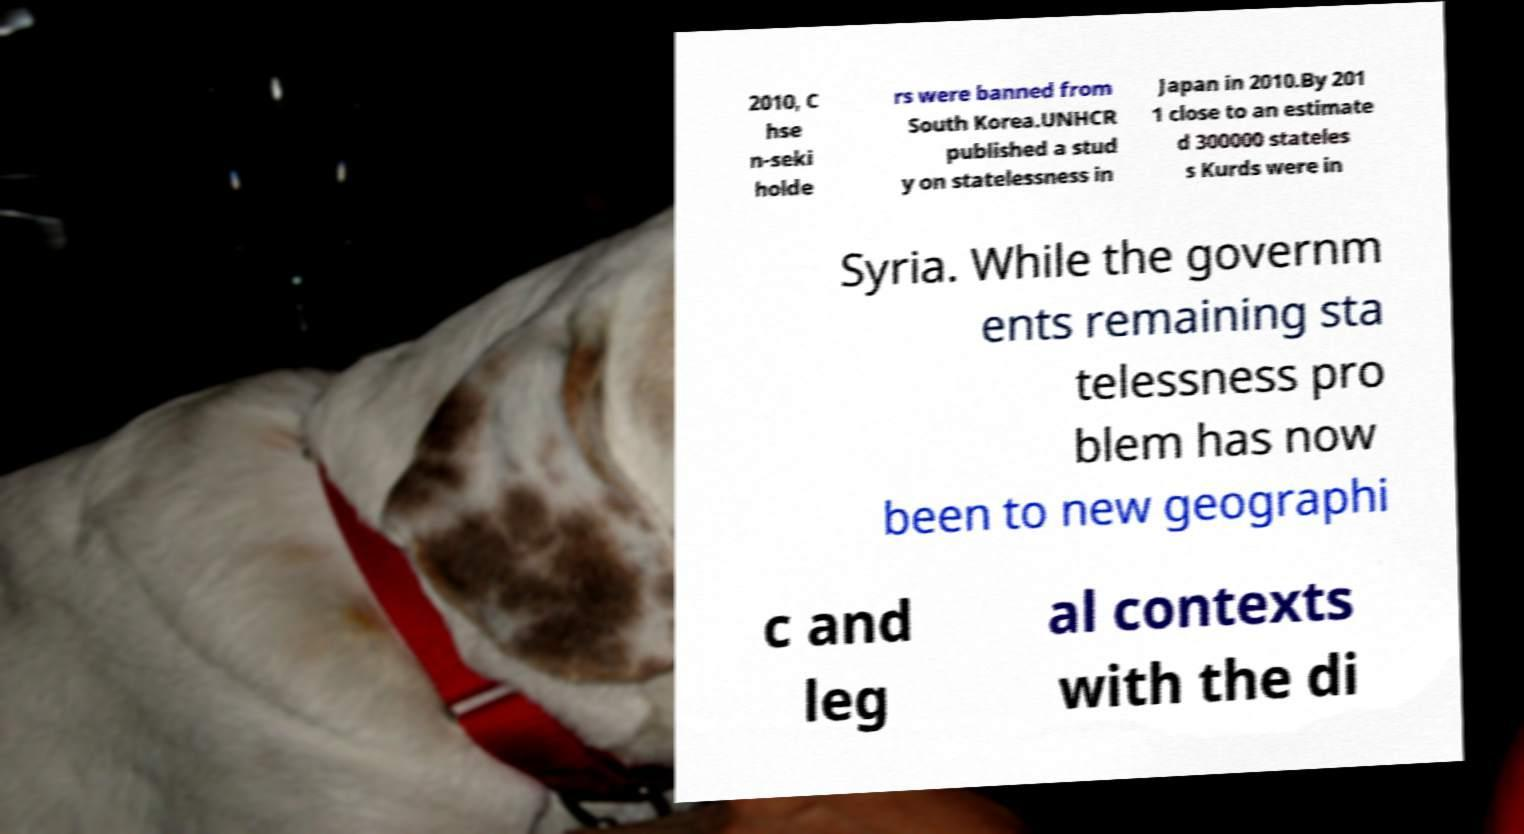I need the written content from this picture converted into text. Can you do that? 2010, C hse n-seki holde rs were banned from South Korea.UNHCR published a stud y on statelessness in Japan in 2010.By 201 1 close to an estimate d 300000 stateles s Kurds were in Syria. While the governm ents remaining sta telessness pro blem has now been to new geographi c and leg al contexts with the di 